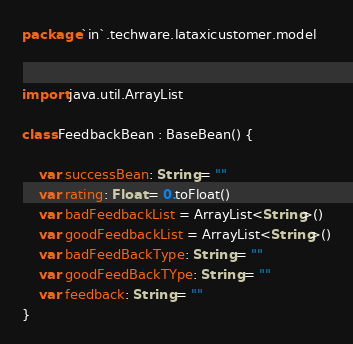Convert code to text. <code><loc_0><loc_0><loc_500><loc_500><_Kotlin_>package `in`.techware.lataxicustomer.model


import java.util.ArrayList

class FeedbackBean : BaseBean() {

    var successBean: String = ""
    var rating: Float = 0.toFloat()
    var badFeedbackList = ArrayList<String>()
    var goodFeedbackList = ArrayList<String>()
    var badFeedBackType: String = ""
    var goodFeedBackTYpe: String = ""
    var feedback: String = ""
}
</code> 